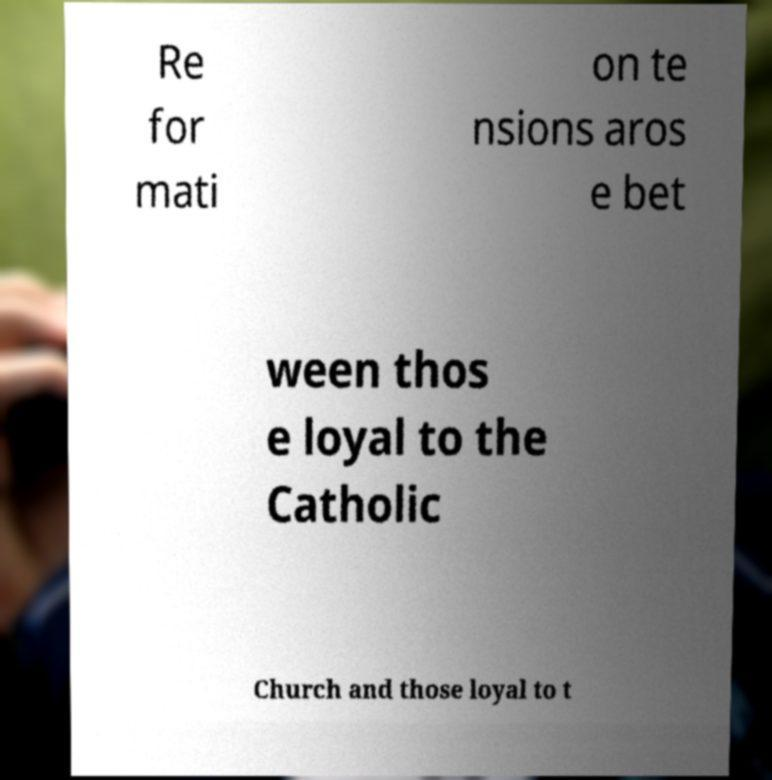I need the written content from this picture converted into text. Can you do that? Re for mati on te nsions aros e bet ween thos e loyal to the Catholic Church and those loyal to t 